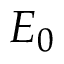Convert formula to latex. <formula><loc_0><loc_0><loc_500><loc_500>E _ { 0 }</formula> 